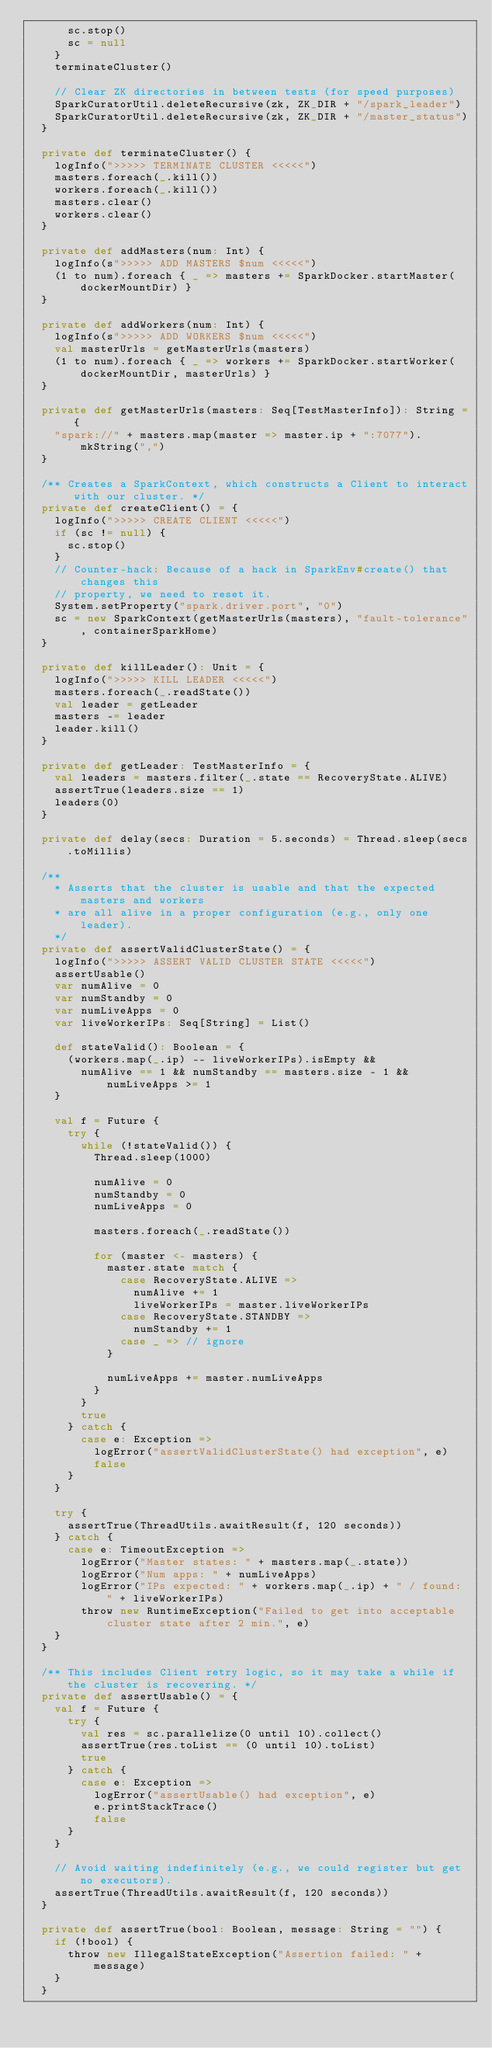<code> <loc_0><loc_0><loc_500><loc_500><_Scala_>      sc.stop()
      sc = null
    }
    terminateCluster()

    // Clear ZK directories in between tests (for speed purposes)
    SparkCuratorUtil.deleteRecursive(zk, ZK_DIR + "/spark_leader")
    SparkCuratorUtil.deleteRecursive(zk, ZK_DIR + "/master_status")
  }

  private def terminateCluster() {
    logInfo(">>>>> TERMINATE CLUSTER <<<<<")
    masters.foreach(_.kill())
    workers.foreach(_.kill())
    masters.clear()
    workers.clear()
  }

  private def addMasters(num: Int) {
    logInfo(s">>>>> ADD MASTERS $num <<<<<")
    (1 to num).foreach { _ => masters += SparkDocker.startMaster(dockerMountDir) }
  }

  private def addWorkers(num: Int) {
    logInfo(s">>>>> ADD WORKERS $num <<<<<")
    val masterUrls = getMasterUrls(masters)
    (1 to num).foreach { _ => workers += SparkDocker.startWorker(dockerMountDir, masterUrls) }
  }

  private def getMasterUrls(masters: Seq[TestMasterInfo]): String = {
    "spark://" + masters.map(master => master.ip + ":7077").mkString(",")
  }

  /** Creates a SparkContext, which constructs a Client to interact with our cluster. */
  private def createClient() = {
    logInfo(">>>>> CREATE CLIENT <<<<<")
    if (sc != null) {
      sc.stop()
    }
    // Counter-hack: Because of a hack in SparkEnv#create() that changes this
    // property, we need to reset it.
    System.setProperty("spark.driver.port", "0")
    sc = new SparkContext(getMasterUrls(masters), "fault-tolerance", containerSparkHome)
  }

  private def killLeader(): Unit = {
    logInfo(">>>>> KILL LEADER <<<<<")
    masters.foreach(_.readState())
    val leader = getLeader
    masters -= leader
    leader.kill()
  }

  private def getLeader: TestMasterInfo = {
    val leaders = masters.filter(_.state == RecoveryState.ALIVE)
    assertTrue(leaders.size == 1)
    leaders(0)
  }

  private def delay(secs: Duration = 5.seconds) = Thread.sleep(secs.toMillis)

  /**
    * Asserts that the cluster is usable and that the expected masters and workers
    * are all alive in a proper configuration (e.g., only one leader).
    */
  private def assertValidClusterState() = {
    logInfo(">>>>> ASSERT VALID CLUSTER STATE <<<<<")
    assertUsable()
    var numAlive = 0
    var numStandby = 0
    var numLiveApps = 0
    var liveWorkerIPs: Seq[String] = List()

    def stateValid(): Boolean = {
      (workers.map(_.ip) -- liveWorkerIPs).isEmpty &&
        numAlive == 1 && numStandby == masters.size - 1 && numLiveApps >= 1
    }

    val f = Future {
      try {
        while (!stateValid()) {
          Thread.sleep(1000)

          numAlive = 0
          numStandby = 0
          numLiveApps = 0

          masters.foreach(_.readState())

          for (master <- masters) {
            master.state match {
              case RecoveryState.ALIVE =>
                numAlive += 1
                liveWorkerIPs = master.liveWorkerIPs
              case RecoveryState.STANDBY =>
                numStandby += 1
              case _ => // ignore
            }

            numLiveApps += master.numLiveApps
          }
        }
        true
      } catch {
        case e: Exception =>
          logError("assertValidClusterState() had exception", e)
          false
      }
    }

    try {
      assertTrue(ThreadUtils.awaitResult(f, 120 seconds))
    } catch {
      case e: TimeoutException =>
        logError("Master states: " + masters.map(_.state))
        logError("Num apps: " + numLiveApps)
        logError("IPs expected: " + workers.map(_.ip) + " / found: " + liveWorkerIPs)
        throw new RuntimeException("Failed to get into acceptable cluster state after 2 min.", e)
    }
  }

  /** This includes Client retry logic, so it may take a while if the cluster is recovering. */
  private def assertUsable() = {
    val f = Future {
      try {
        val res = sc.parallelize(0 until 10).collect()
        assertTrue(res.toList == (0 until 10).toList)
        true
      } catch {
        case e: Exception =>
          logError("assertUsable() had exception", e)
          e.printStackTrace()
          false
      }
    }

    // Avoid waiting indefinitely (e.g., we could register but get no executors).
    assertTrue(ThreadUtils.awaitResult(f, 120 seconds))
  }

  private def assertTrue(bool: Boolean, message: String = "") {
    if (!bool) {
      throw new IllegalStateException("Assertion failed: " + message)
    }
  }
</code> 